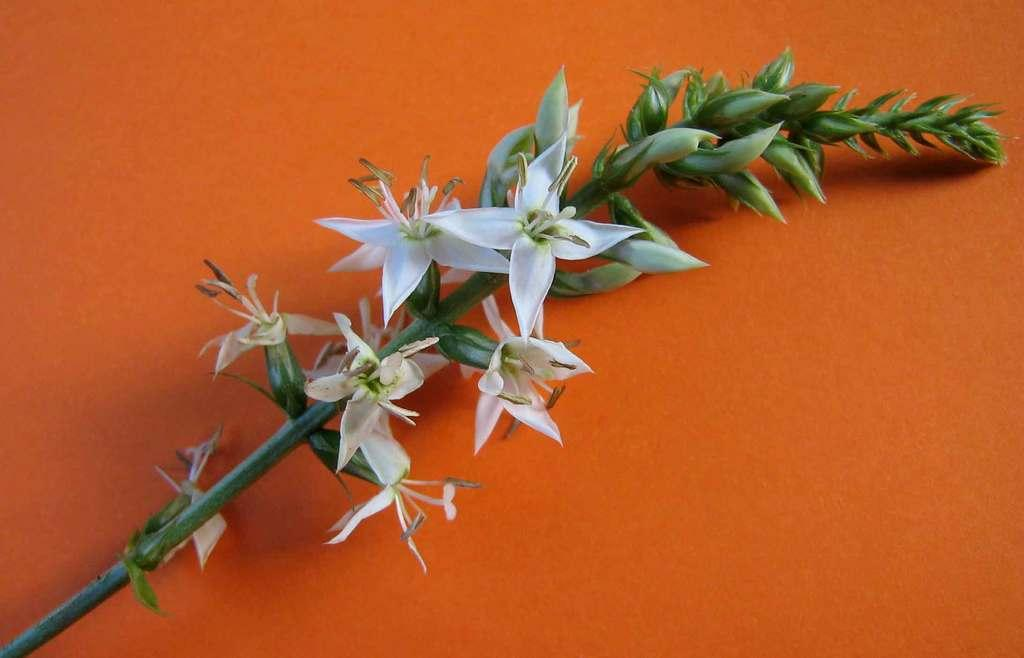What type of living organisms can be seen in the image? There are flowers in the image. What color is the background of the image? The background of the image is orange in color. Can you hear a whistle in the image? There is no whistle present in the image, as it is a visual medium and does not contain sound. 